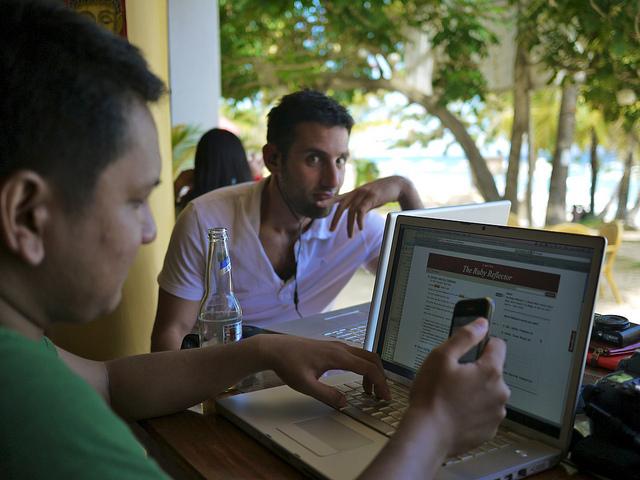Is someone holding a phone?
Quick response, please. Yes. What is the bottle on the table?
Answer briefly. Beer. How many laptops are there?
Keep it brief. 2. Does he look mad?
Give a very brief answer. No. Is the man riding in some sort of a vehicle?
Give a very brief answer. No. Does the man wear a watch?
Quick response, please. No. 